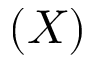Convert formula to latex. <formula><loc_0><loc_0><loc_500><loc_500>( X )</formula> 